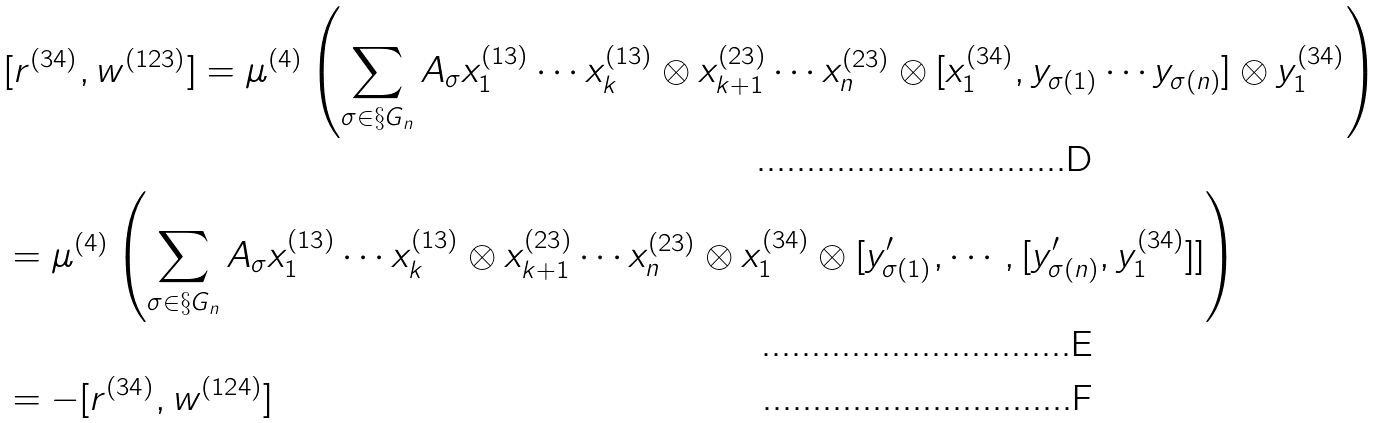Convert formula to latex. <formula><loc_0><loc_0><loc_500><loc_500>& [ r ^ { ( 3 4 ) } , w ^ { ( 1 2 3 ) } ] = \mu ^ { ( 4 ) } \left ( \sum _ { \sigma \in \S G _ { n } } A _ { \sigma } x ^ { ( 1 3 ) } _ { 1 } \cdots x ^ { ( 1 3 ) } _ { k } \otimes x ^ { ( 2 3 ) } _ { k + 1 } \cdots x ^ { ( 2 3 ) } _ { n } \otimes [ x ^ { ( 3 4 ) } _ { 1 } , y _ { \sigma ( 1 ) } \cdots y _ { \sigma ( n ) } ] \otimes y ^ { ( 3 4 ) } _ { 1 } \right ) \\ & = \mu ^ { ( 4 ) } \left ( \sum _ { \sigma \in \S G _ { n } } A _ { \sigma } x ^ { ( 1 3 ) } _ { 1 } \cdots x ^ { ( 1 3 ) } _ { k } \otimes x ^ { ( 2 3 ) } _ { k + 1 } \cdots x ^ { ( 2 3 ) } _ { n } \otimes x ^ { ( 3 4 ) } _ { 1 } \otimes [ y ^ { \prime } _ { \sigma ( 1 ) } , \cdots , [ y ^ { \prime } _ { \sigma ( n ) } , y ^ { ( 3 4 ) } _ { 1 } ] ] \right ) \\ & = - [ r ^ { ( 3 4 ) } , w ^ { ( 1 2 4 ) } ]</formula> 